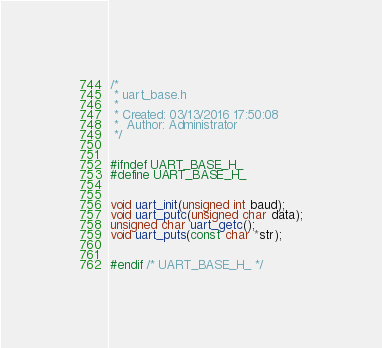<code> <loc_0><loc_0><loc_500><loc_500><_C_>/*
 * uart_base.h
 *
 * Created: 03/13/2016 17:50:08
 *  Author: Administrator
 */ 


#ifndef UART_BASE_H_
#define UART_BASE_H_


void uart_init(unsigned int baud);
void uart_putc(unsigned char data);
unsigned char uart_getc();
void uart_puts(const char *str);


#endif /* UART_BASE_H_ */</code> 